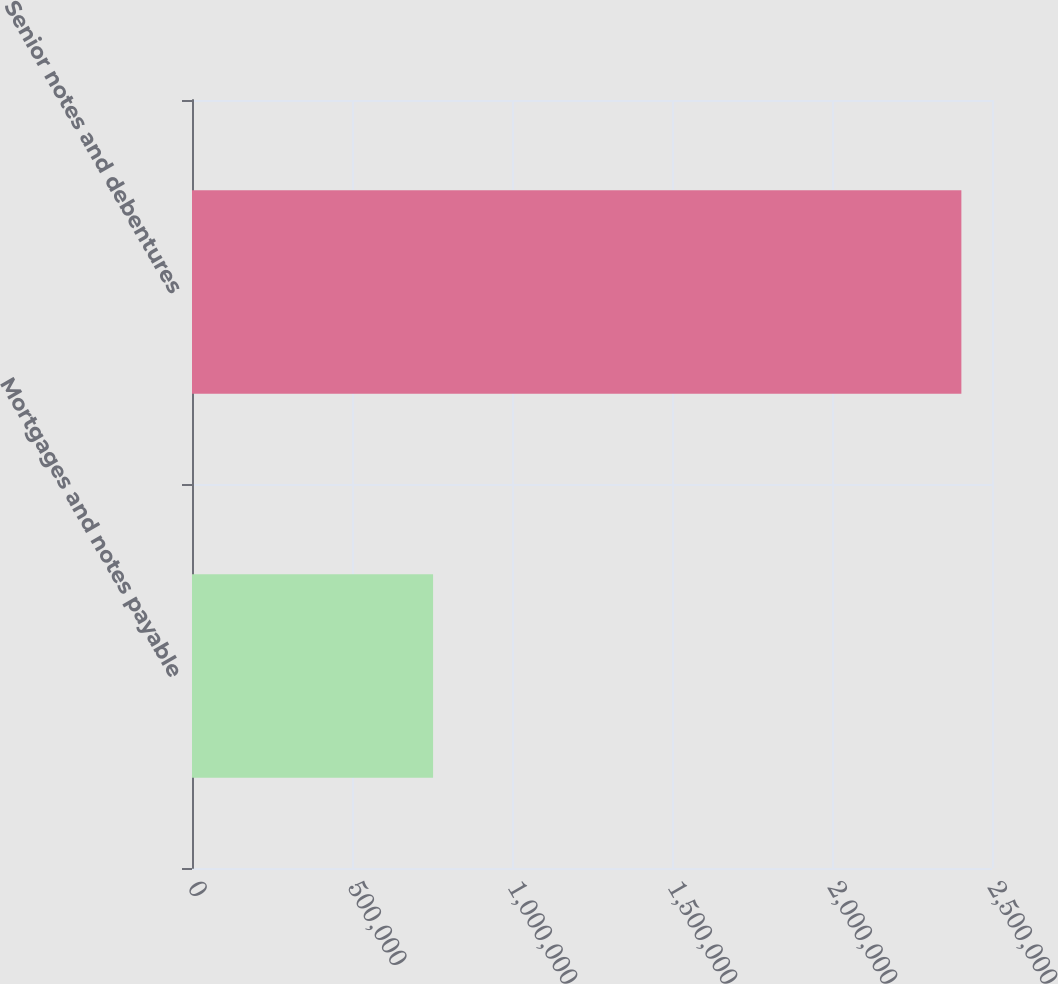Convert chart to OTSL. <chart><loc_0><loc_0><loc_500><loc_500><bar_chart><fcel>Mortgages and notes payable<fcel>Senior notes and debentures<nl><fcel>753406<fcel>2.40428e+06<nl></chart> 